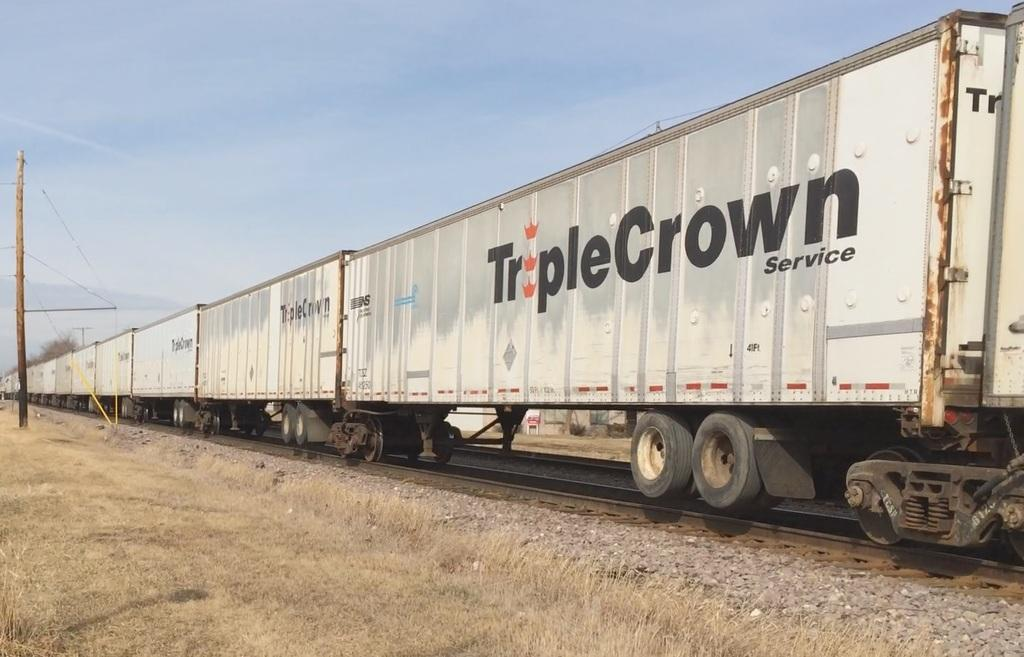Provide a one-sentence caption for the provided image. A row of TripleCrown Service train cars are on a train track. 